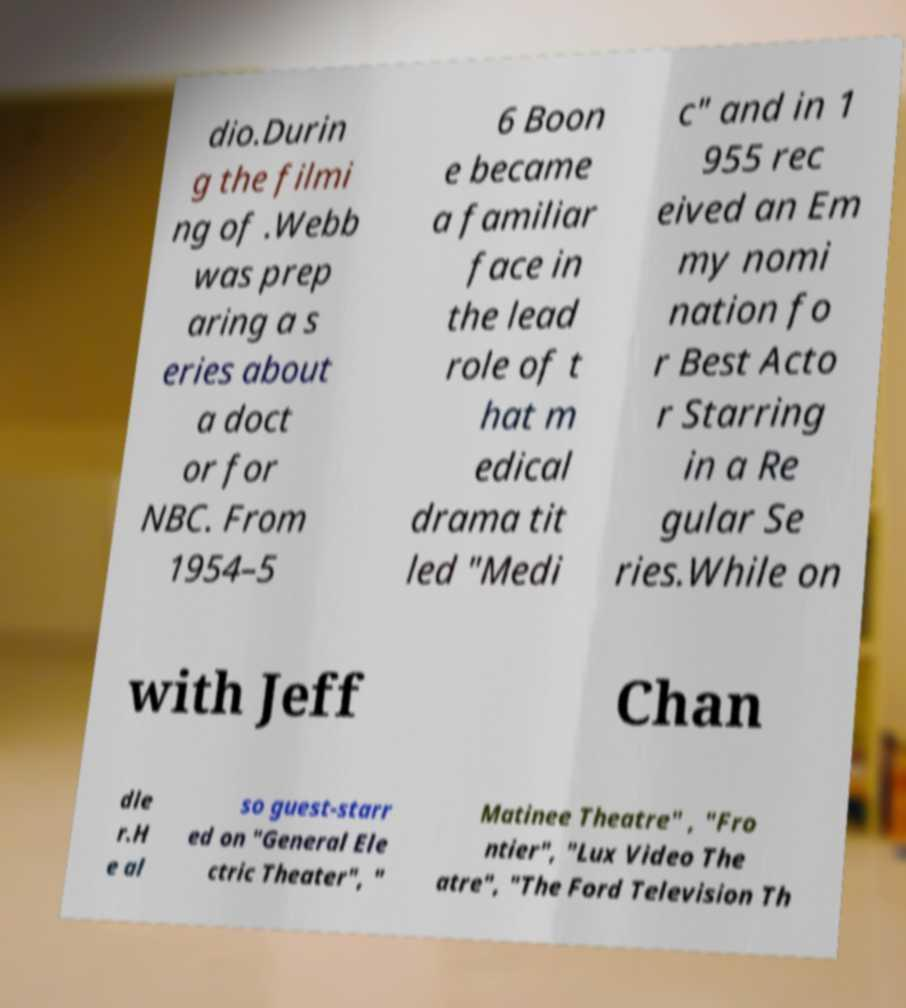Please read and relay the text visible in this image. What does it say? dio.Durin g the filmi ng of .Webb was prep aring a s eries about a doct or for NBC. From 1954–5 6 Boon e became a familiar face in the lead role of t hat m edical drama tit led "Medi c" and in 1 955 rec eived an Em my nomi nation fo r Best Acto r Starring in a Re gular Se ries.While on with Jeff Chan dle r.H e al so guest-starr ed on "General Ele ctric Theater", " Matinee Theatre" , "Fro ntier", "Lux Video The atre", "The Ford Television Th 